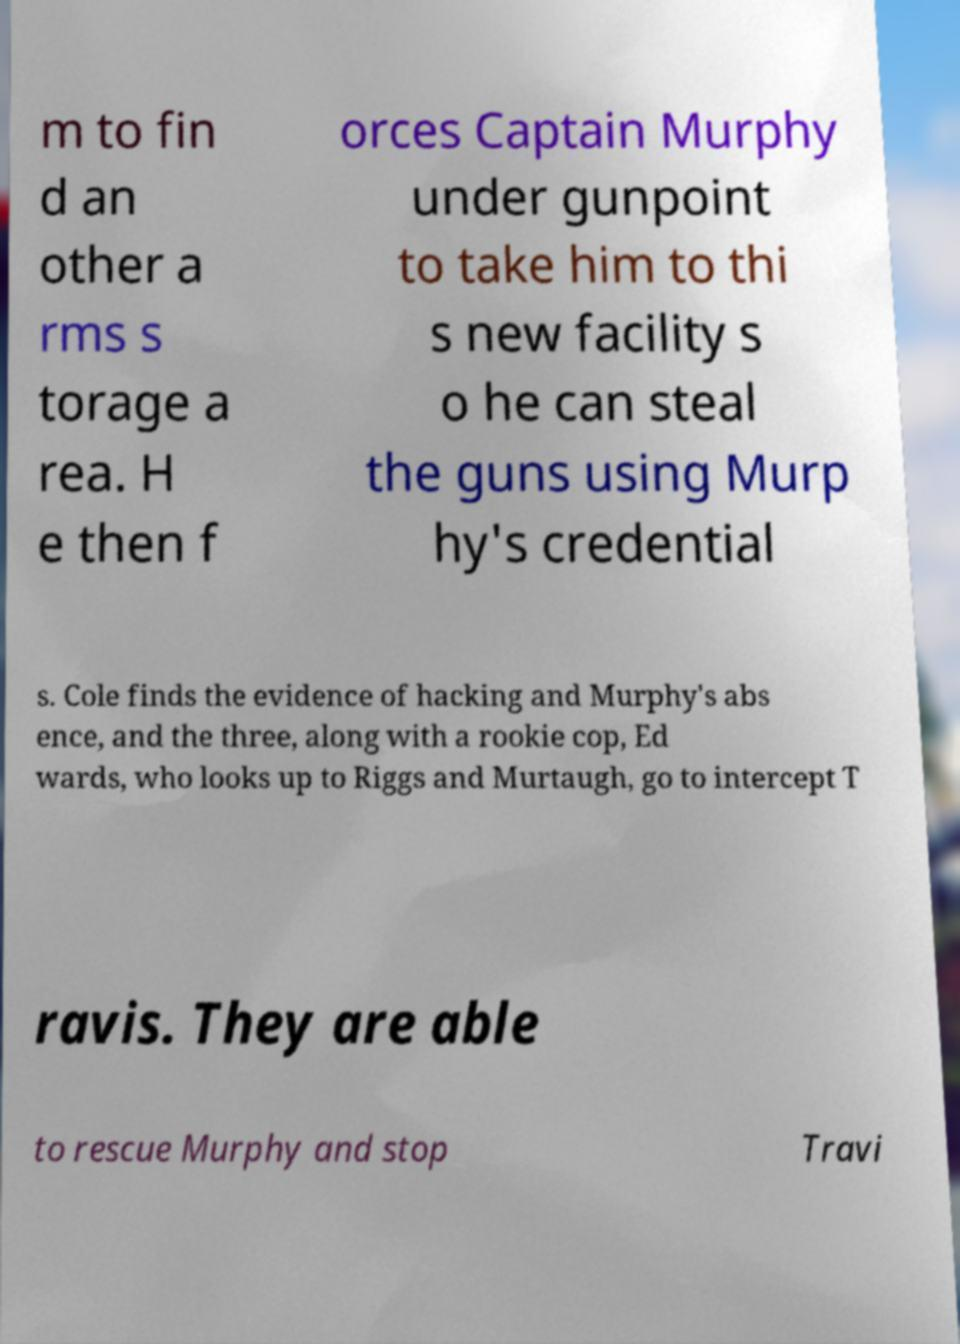Could you extract and type out the text from this image? m to fin d an other a rms s torage a rea. H e then f orces Captain Murphy under gunpoint to take him to thi s new facility s o he can steal the guns using Murp hy's credential s. Cole finds the evidence of hacking and Murphy's abs ence, and the three, along with a rookie cop, Ed wards, who looks up to Riggs and Murtaugh, go to intercept T ravis. They are able to rescue Murphy and stop Travi 